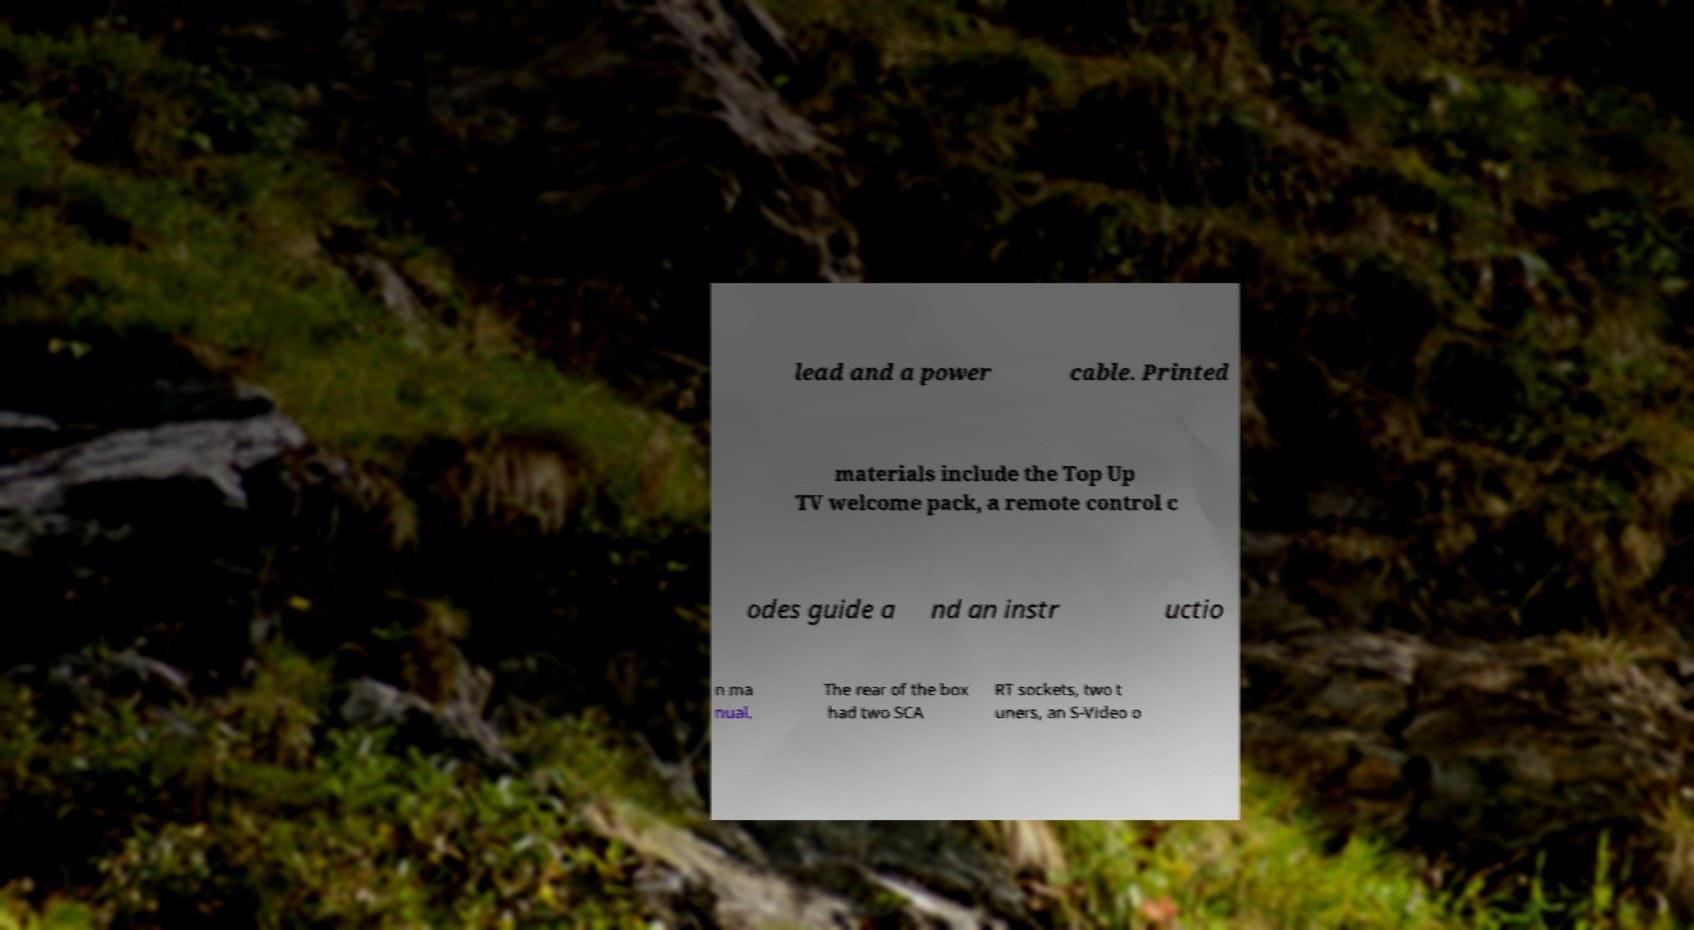Could you extract and type out the text from this image? lead and a power cable. Printed materials include the Top Up TV welcome pack, a remote control c odes guide a nd an instr uctio n ma nual. The rear of the box had two SCA RT sockets, two t uners, an S-Video o 